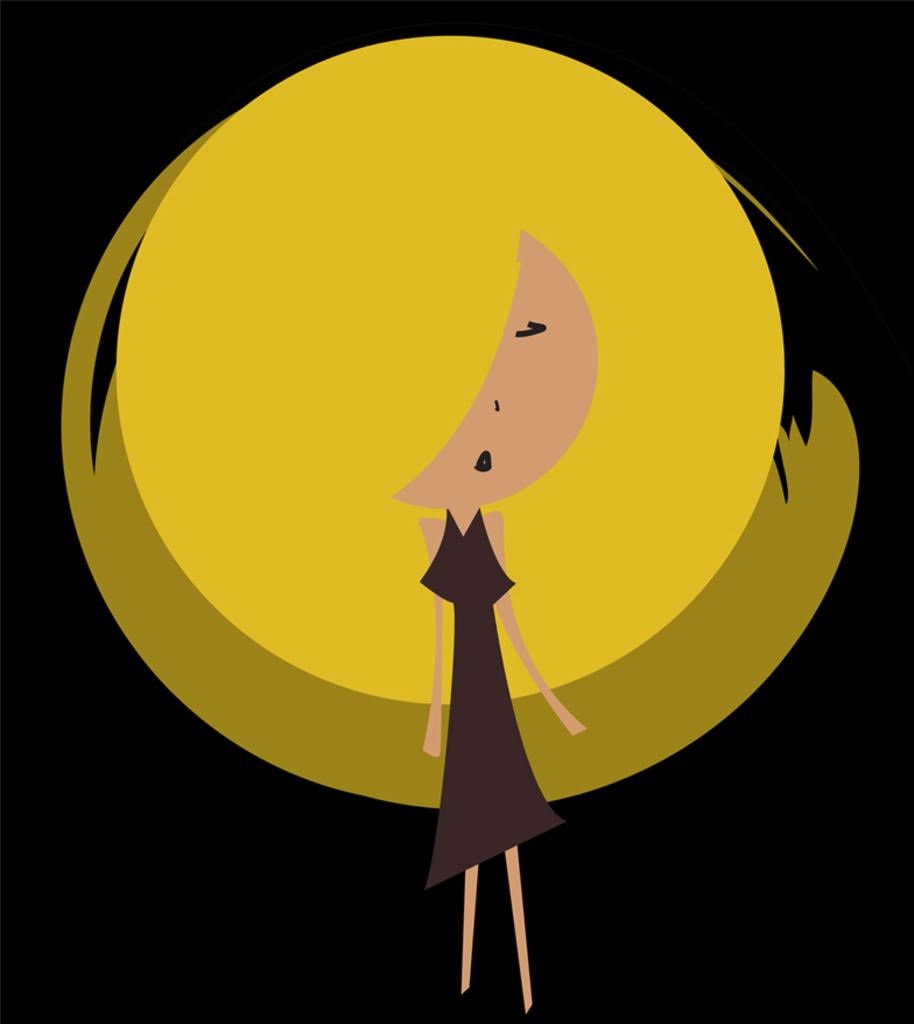What type of picture is depicted in the image? The image contains an animated picture. Can you describe the main subject in the image? There is a girl in the center of the image. What can be seen behind the girl? There are yellow circles behind the girl. How would you describe the overall color scheme of the image? The background of the image is dark. What type of treatment is the girl receiving in the image? There is no indication in the image that the girl is receiving any treatment. Can you see any snails in the image? There are no snails present in the image. 